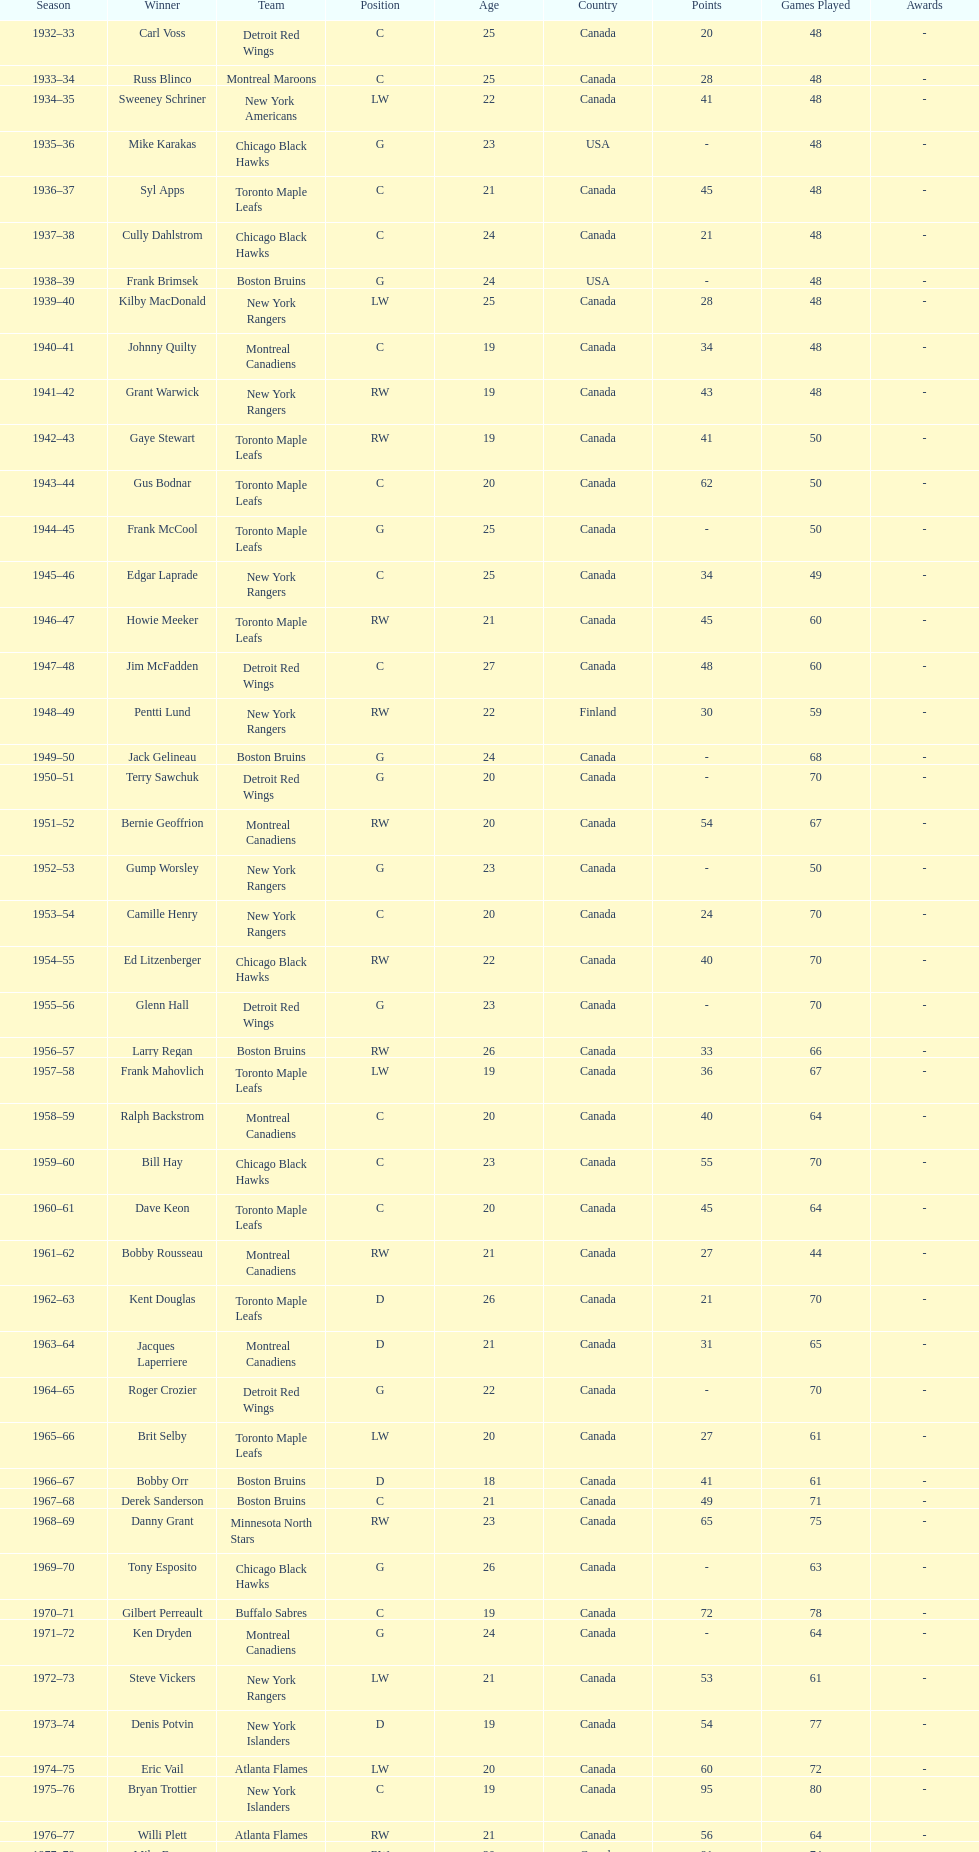Which team has the highest number of consecutive calder memorial trophy winners? Toronto Maple Leafs. 